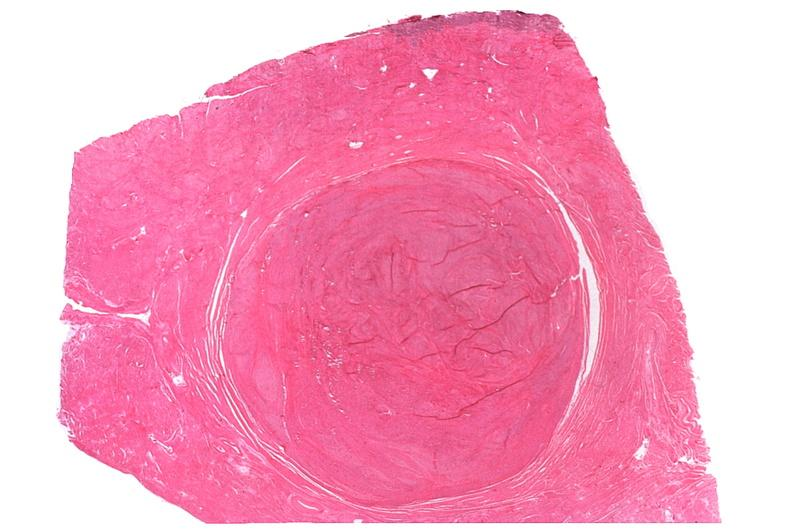s spina bifida present?
Answer the question using a single word or phrase. No 